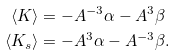<formula> <loc_0><loc_0><loc_500><loc_500>\langle K \rangle & = - A ^ { - 3 } \alpha - A ^ { 3 } \beta \\ \langle K _ { s } \rangle & = - A ^ { 3 } \alpha - A ^ { - 3 } \beta .</formula> 